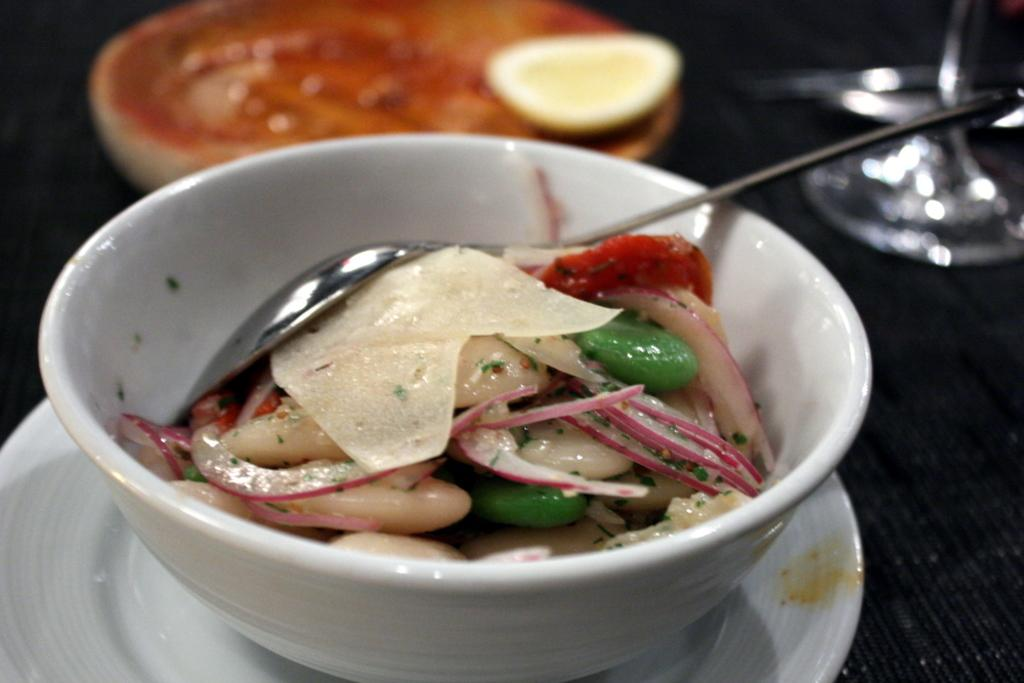What is in the bowl that is visible in the image? There is a white bowl of food item in the image. What utensil is present in the bowl? A spoon is present in the bowl. What is located below the bowl? There is a white plate below the bowl. How would you describe the background of the image? The background of the image is blurred. What type of rifle can be seen on the plate in the image? There is no rifle present in the image; it features a white bowl of food item, a spoon, and a white plate. Can you tell me how many cubs are visible in the image? There are no cubs present in the image. 